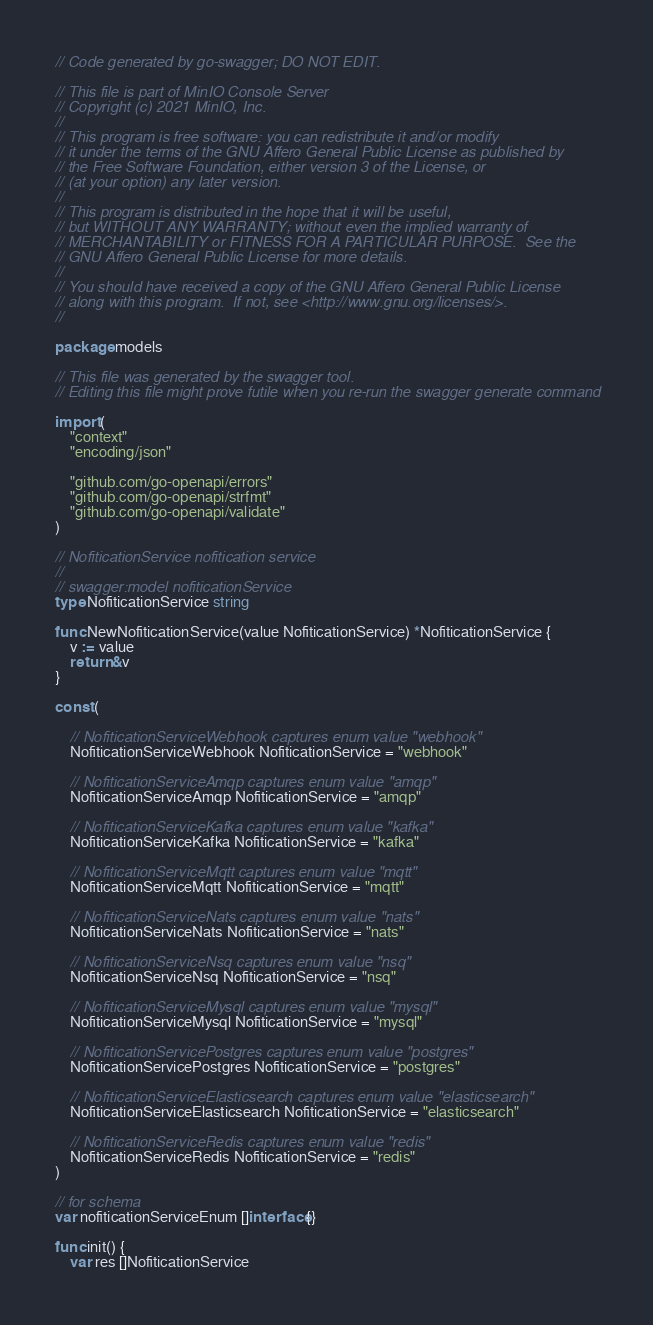Convert code to text. <code><loc_0><loc_0><loc_500><loc_500><_Go_>// Code generated by go-swagger; DO NOT EDIT.

// This file is part of MinIO Console Server
// Copyright (c) 2021 MinIO, Inc.
//
// This program is free software: you can redistribute it and/or modify
// it under the terms of the GNU Affero General Public License as published by
// the Free Software Foundation, either version 3 of the License, or
// (at your option) any later version.
//
// This program is distributed in the hope that it will be useful,
// but WITHOUT ANY WARRANTY; without even the implied warranty of
// MERCHANTABILITY or FITNESS FOR A PARTICULAR PURPOSE.  See the
// GNU Affero General Public License for more details.
//
// You should have received a copy of the GNU Affero General Public License
// along with this program.  If not, see <http://www.gnu.org/licenses/>.
//

package models

// This file was generated by the swagger tool.
// Editing this file might prove futile when you re-run the swagger generate command

import (
	"context"
	"encoding/json"

	"github.com/go-openapi/errors"
	"github.com/go-openapi/strfmt"
	"github.com/go-openapi/validate"
)

// NofiticationService nofitication service
//
// swagger:model nofiticationService
type NofiticationService string

func NewNofiticationService(value NofiticationService) *NofiticationService {
	v := value
	return &v
}

const (

	// NofiticationServiceWebhook captures enum value "webhook"
	NofiticationServiceWebhook NofiticationService = "webhook"

	// NofiticationServiceAmqp captures enum value "amqp"
	NofiticationServiceAmqp NofiticationService = "amqp"

	// NofiticationServiceKafka captures enum value "kafka"
	NofiticationServiceKafka NofiticationService = "kafka"

	// NofiticationServiceMqtt captures enum value "mqtt"
	NofiticationServiceMqtt NofiticationService = "mqtt"

	// NofiticationServiceNats captures enum value "nats"
	NofiticationServiceNats NofiticationService = "nats"

	// NofiticationServiceNsq captures enum value "nsq"
	NofiticationServiceNsq NofiticationService = "nsq"

	// NofiticationServiceMysql captures enum value "mysql"
	NofiticationServiceMysql NofiticationService = "mysql"

	// NofiticationServicePostgres captures enum value "postgres"
	NofiticationServicePostgres NofiticationService = "postgres"

	// NofiticationServiceElasticsearch captures enum value "elasticsearch"
	NofiticationServiceElasticsearch NofiticationService = "elasticsearch"

	// NofiticationServiceRedis captures enum value "redis"
	NofiticationServiceRedis NofiticationService = "redis"
)

// for schema
var nofiticationServiceEnum []interface{}

func init() {
	var res []NofiticationService</code> 